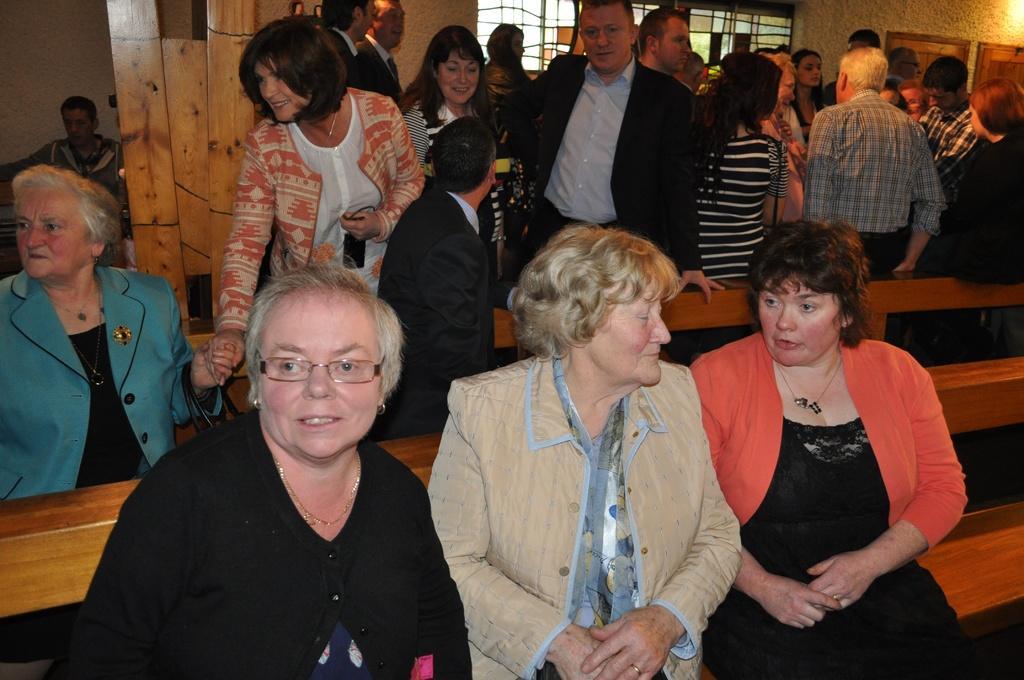Please provide a concise description of this image. In the image there are few people sitting on the benches. Behind them there are many people standing. In the background there are glass windows and frames on the walls. And also there is a wooden pillar. 